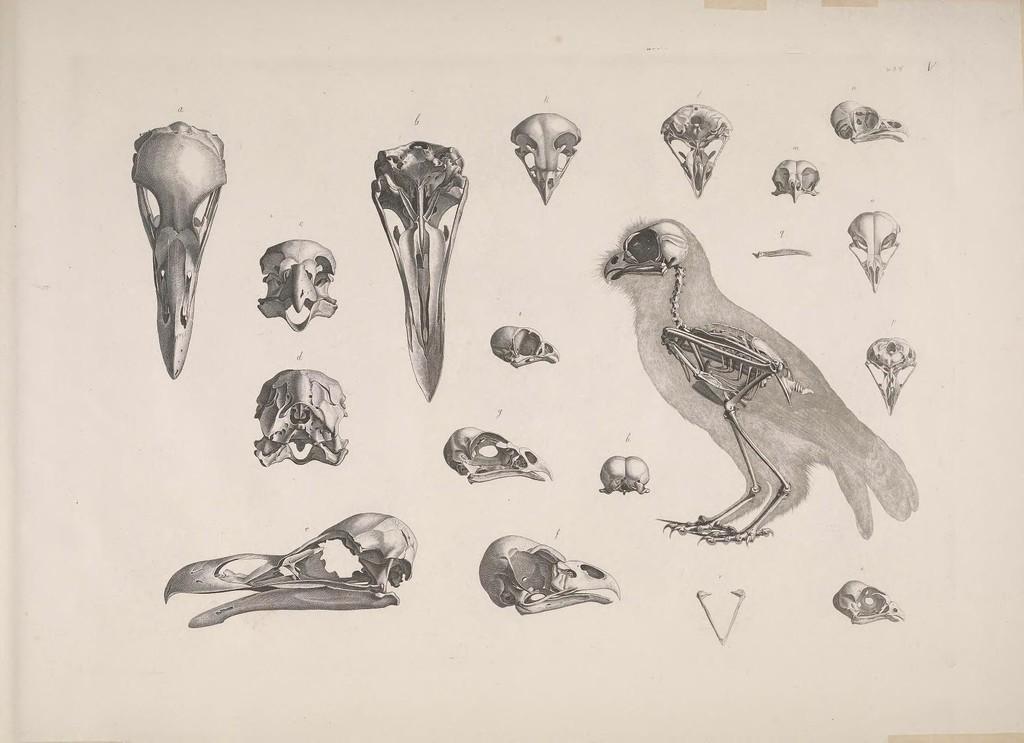Could you give a brief overview of what you see in this image? This is a picture of a bird in this image there are some bones and skull, and the background is white in color. 